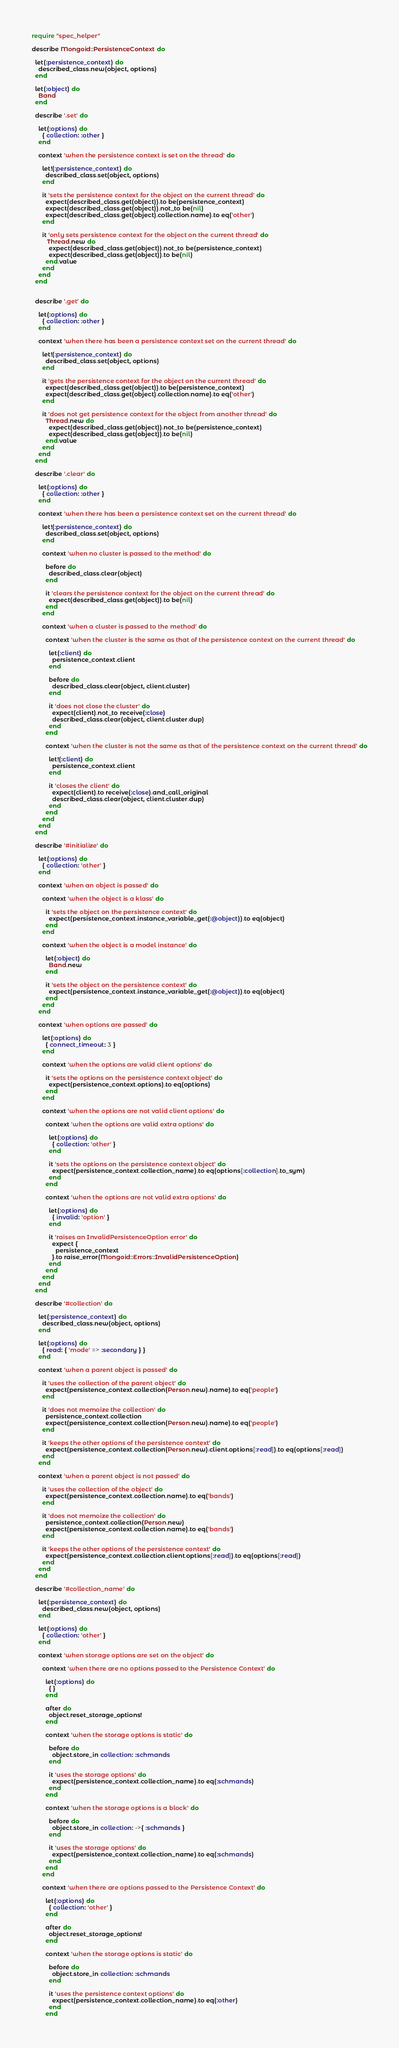<code> <loc_0><loc_0><loc_500><loc_500><_Ruby_>require "spec_helper"

describe Mongoid::PersistenceContext do

  let(:persistence_context) do
    described_class.new(object, options)
  end

  let(:object) do
    Band
  end

  describe '.set' do

    let(:options) do
      { collection: :other }
    end

    context 'when the persistence context is set on the thread' do

      let!(:persistence_context) do
        described_class.set(object, options)
      end

      it 'sets the persistence context for the object on the current thread' do
        expect(described_class.get(object)).to be(persistence_context)
        expect(described_class.get(object)).not_to be(nil)
        expect(described_class.get(object).collection.name).to eq('other')
      end

      it 'only sets persistence context for the object on the current thread' do
         Thread.new do
          expect(described_class.get(object)).not_to be(persistence_context)
          expect(described_class.get(object)).to be(nil)
        end.value
      end
    end
  end


  describe '.get' do

    let(:options) do
      { collection: :other }
    end

    context 'when there has been a persistence context set on the current thread' do

      let!(:persistence_context) do
        described_class.set(object, options)
      end

      it 'gets the persistence context for the object on the current thread' do
        expect(described_class.get(object)).to be(persistence_context)
        expect(described_class.get(object).collection.name).to eq('other')
      end

      it 'does not get persistence context for the object from another thread' do
        Thread.new do
          expect(described_class.get(object)).not_to be(persistence_context)
          expect(described_class.get(object)).to be(nil)
        end.value
      end
    end
  end

  describe '.clear' do

    let(:options) do
      { collection: :other }
    end

    context 'when there has been a persistence context set on the current thread' do

      let!(:persistence_context) do
        described_class.set(object, options)
      end

      context 'when no cluster is passed to the method' do

        before do
          described_class.clear(object)
        end

        it 'clears the persistence context for the object on the current thread' do
          expect(described_class.get(object)).to be(nil)
        end
      end

      context 'when a cluster is passed to the method' do

        context 'when the cluster is the same as that of the persistence context on the current thread' do

          let(:client) do
            persistence_context.client
          end

          before do
            described_class.clear(object, client.cluster)
          end

          it 'does not close the cluster' do
            expect(client).not_to receive(:close)
            described_class.clear(object, client.cluster.dup)
          end
        end

        context 'when the cluster is not the same as that of the persistence context on the current thread' do

          let!(:client) do
            persistence_context.client
          end

          it 'closes the client' do
            expect(client).to receive(:close).and_call_original
            described_class.clear(object, client.cluster.dup)
          end
        end
      end
    end
  end

  describe '#initialize' do

    let(:options) do
      { collection: 'other' }
    end

    context 'when an object is passed' do

      context 'when the object is a klass' do

        it 'sets the object on the persistence context' do
          expect(persistence_context.instance_variable_get(:@object)).to eq(object)
        end
      end

      context 'when the object is a model instance' do

        let(:object) do
          Band.new
        end

        it 'sets the object on the persistence context' do
          expect(persistence_context.instance_variable_get(:@object)).to eq(object)
        end
      end
    end

    context 'when options are passed' do

      let(:options) do
        { connect_timeout: 3 }
      end

      context 'when the options are valid client options' do

        it 'sets the options on the persistence context object' do
          expect(persistence_context.options).to eq(options)
        end
      end

      context 'when the options are not valid client options' do

        context 'when the options are valid extra options' do

          let(:options) do
            { collection: 'other' }
          end

          it 'sets the options on the persistence context object' do
            expect(persistence_context.collection_name).to eq(options[:collection].to_sym)
          end
        end

        context 'when the options are not valid extra options' do

          let(:options) do
            { invalid: 'option' }
          end

          it 'raises an InvalidPersistenceOption error' do
            expect {
              persistence_context
            }.to raise_error(Mongoid::Errors::InvalidPersistenceOption)
          end
        end
      end
    end
  end

  describe '#collection' do

    let(:persistence_context) do
      described_class.new(object, options)
    end

    let(:options) do
      { read: { 'mode' => :secondary } }
    end

    context 'when a parent object is passed' do

      it 'uses the collection of the parent object' do
        expect(persistence_context.collection(Person.new).name).to eq('people')
      end

      it 'does not memoize the collection' do
        persistence_context.collection
        expect(persistence_context.collection(Person.new).name).to eq('people')
      end

      it 'keeps the other options of the persistence context' do
        expect(persistence_context.collection(Person.new).client.options[:read]).to eq(options[:read])
      end
    end

    context 'when a parent object is not passed' do

      it 'uses the collection of the object' do
        expect(persistence_context.collection.name).to eq('bands')
      end

      it 'does not memoize the collection' do
        persistence_context.collection(Person.new)
        expect(persistence_context.collection.name).to eq('bands')
      end

      it 'keeps the other options of the persistence context' do
        expect(persistence_context.collection.client.options[:read]).to eq(options[:read])
      end
    end
  end

  describe '#collection_name' do

    let(:persistence_context) do
      described_class.new(object, options)
    end

    let(:options) do
      { collection: 'other' }
    end

    context 'when storage options are set on the object' do

      context 'when there are no options passed to the Persistence Context' do

        let(:options) do
          { }
        end

        after do
          object.reset_storage_options!
        end

        context 'when the storage options is static' do

          before do
            object.store_in collection: :schmands
          end

          it 'uses the storage options' do
            expect(persistence_context.collection_name).to eq(:schmands)
          end
        end

        context 'when the storage options is a block' do

          before do
            object.store_in collection: ->{ :schmands }
          end

          it 'uses the storage options' do
            expect(persistence_context.collection_name).to eq(:schmands)
          end
        end
      end

      context 'when there are options passed to the Persistence Context' do

        let(:options) do
          { collection: 'other' }
        end

        after do
          object.reset_storage_options!
        end

        context 'when the storage options is static' do

          before do
            object.store_in collection: :schmands
          end

          it 'uses the persistence context options' do
            expect(persistence_context.collection_name).to eq(:other)
          end
        end
</code> 